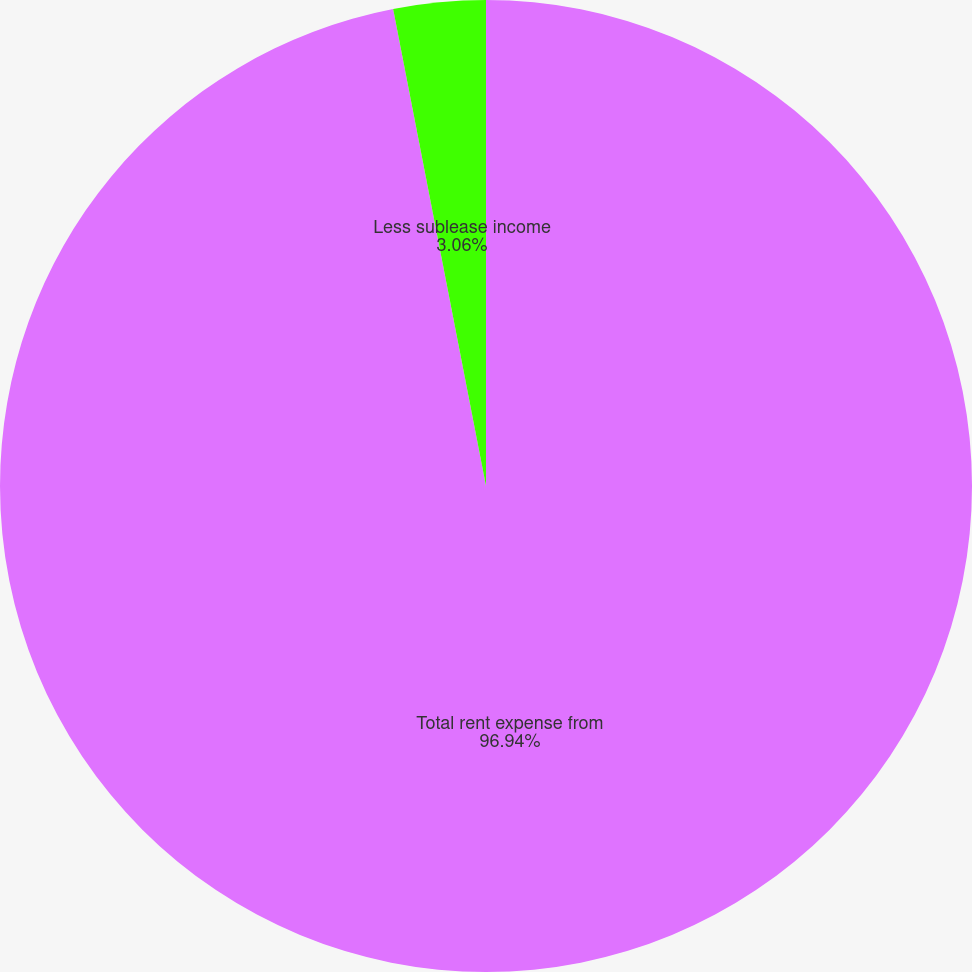<chart> <loc_0><loc_0><loc_500><loc_500><pie_chart><fcel>Total rent expense from<fcel>Less sublease income<nl><fcel>96.94%<fcel>3.06%<nl></chart> 